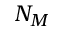<formula> <loc_0><loc_0><loc_500><loc_500>N _ { M }</formula> 